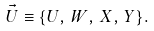<formula> <loc_0><loc_0><loc_500><loc_500>\vec { U } \equiv \{ U , \, W , \, X , \, Y \} .</formula> 